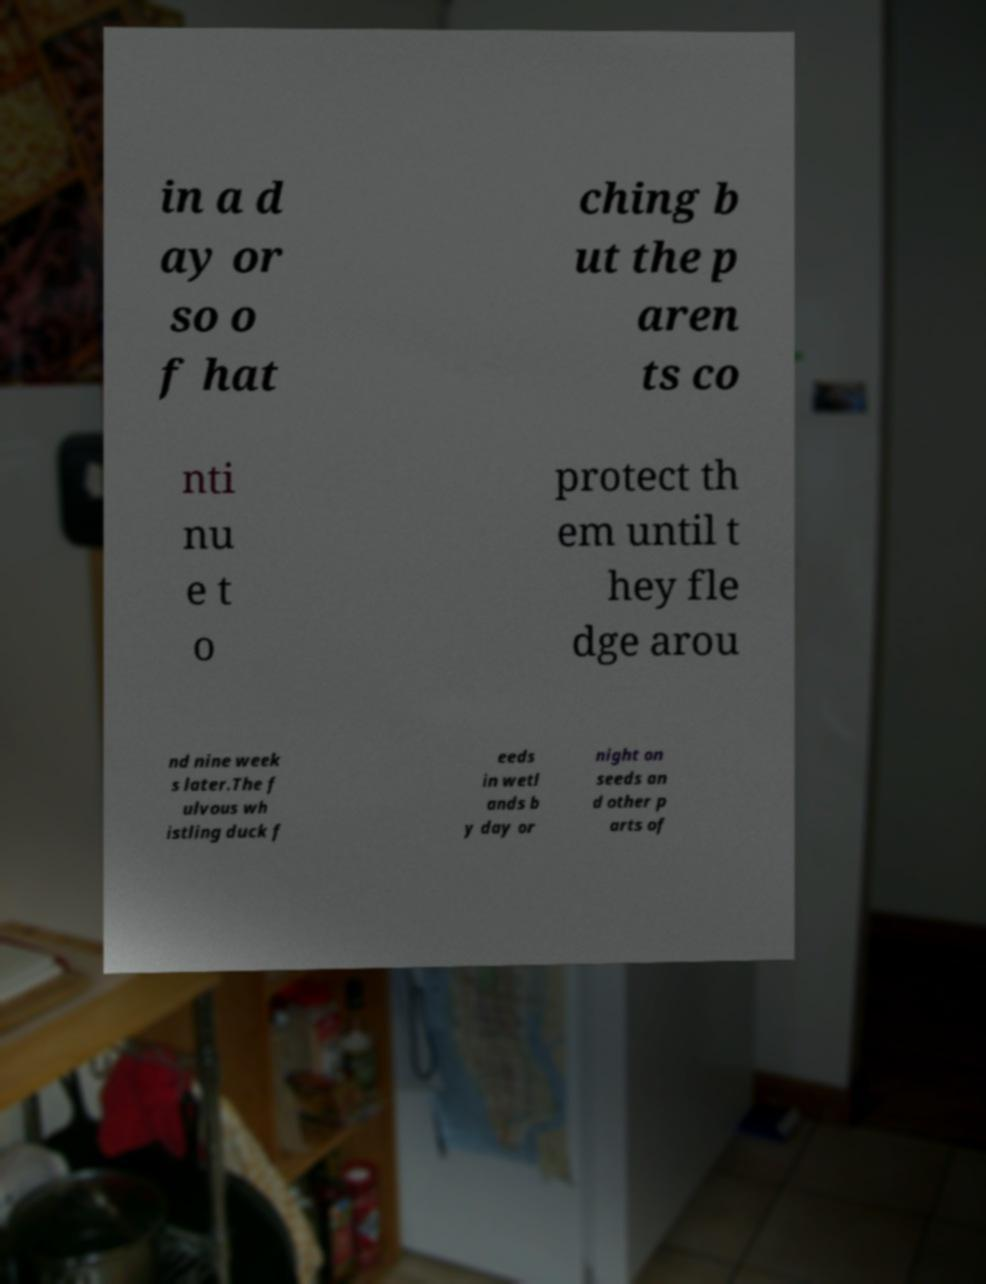For documentation purposes, I need the text within this image transcribed. Could you provide that? in a d ay or so o f hat ching b ut the p aren ts co nti nu e t o protect th em until t hey fle dge arou nd nine week s later.The f ulvous wh istling duck f eeds in wetl ands b y day or night on seeds an d other p arts of 